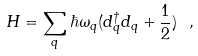Convert formula to latex. <formula><loc_0><loc_0><loc_500><loc_500>H = \sum _ { q } \hbar { \omega } _ { q } ( d _ { q } ^ { \dagger } d _ { q } + \frac { 1 } { 2 } ) \ ,</formula> 